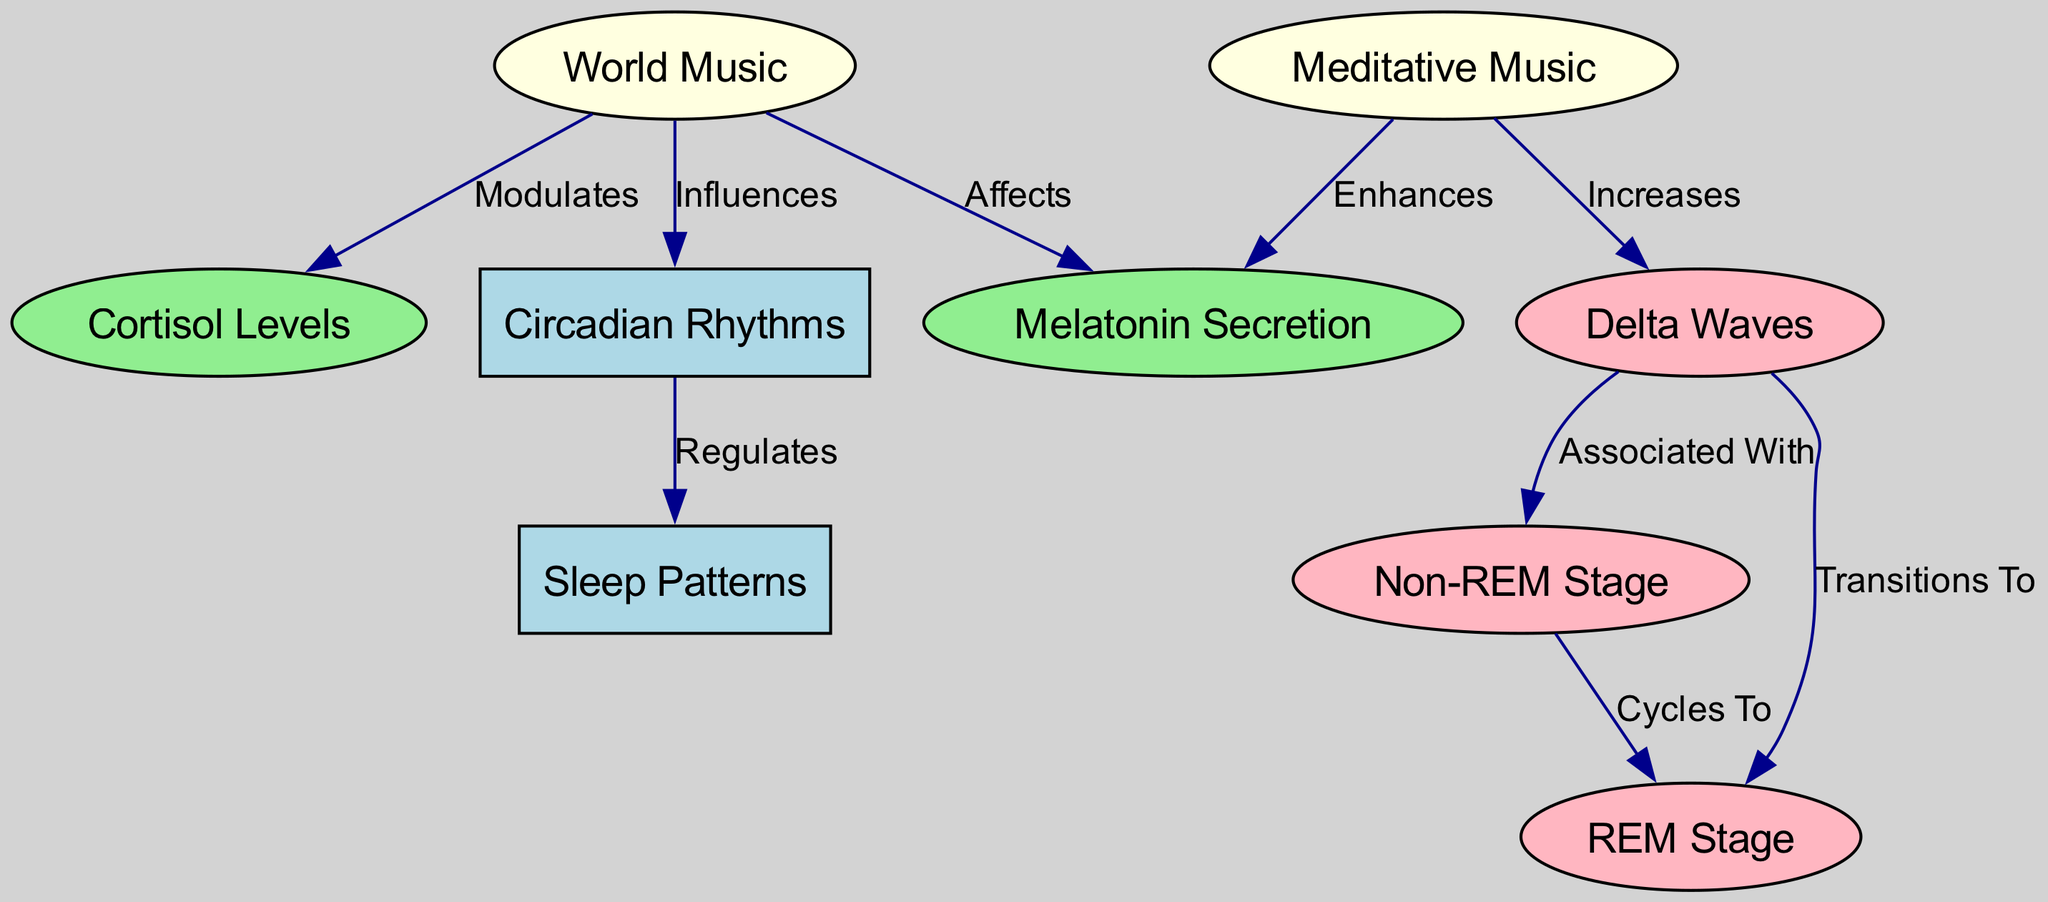What are the main nodes in this diagram? The main nodes in the diagram are the ones listed under the "nodes" section, specifically "Circadian Rhythms," "Sleep Patterns," "World Music," "Melatonin Secretion," "Cortisol Levels," "Meditative Music," "Delta Waves," "REM Stage," and "Non-REM Stage."
Answer: Circadian Rhythms, Sleep Patterns, World Music, Melatonin Secretion, Cortisol Levels, Meditative Music, Delta Waves, REM Stage, Non-REM Stage How many edges are in the diagram? The edges indicate the relationships driving the connections between the nodes. The count can be determined by inspecting the "edges" section, which shows there are 9 edges linking the nodes.
Answer: 9 What node influences Circadian Rhythms? The diagram shows that "World Music" has an arrow pointing to "Circadian Rhythms," indicating that it influences this node.
Answer: World Music Which node is associated with Delta Waves? According to the diagram, "Delta Waves" is associated with the nodes "Non-REM Stage" and "REM Stage," indicating a relationship.
Answer: Non-REM Stage, REM Stage What effect does Meditative Music have on Melatonin Secretion? The diagram indicates a relationship where "Meditative Music" enhances "Melatonin Secretion," suggesting that listening to this type of music positively impacts melatonin levels.
Answer: Enhances Which two stages cycle to each other in the diagram? The edge between "Non-REM Stage" and "REM Stage" shows a cyclical relationship, meaning they influence or transition into each other within the sleep cycle.
Answer: Non-REM Stage, REM Stage What relationship exists between World Music and Cortisol Levels? The diagram shows that "World Music" modulates "Cortisol Levels," indicating that listening to world music can alter cortisol (“stress hormone”) levels in the body.
Answer: Modulates How does Delta Waves relate to Non-REM Stage? The diagram specifies that "Delta Waves" are associated with the "Non-REM Stage," which means that delta waves occur during this stage of sleep and may signal its presence or enhance it.
Answer: Associated With What does Melatonin Secretion affect? Based on the edges, "Melatonin Secretion" is not directly linked to other nodes in this diagram; rather, it is affected by "World Music" and enhanced by "Meditative Music." Thus, it serves as an outcome of these influences.
Answer: Affected by World Music, Enhanced by Meditative Music How does World Music impact Sleep Patterns? "World Music" influences "Circadian Rhythms," and since "Circadian Rhythms" regulate "Sleep Patterns," it can be concluded that world music has a secondary impact on sleep patterns through its influence on circadian rhythms.
Answer: Influences through Circadian Rhythms 